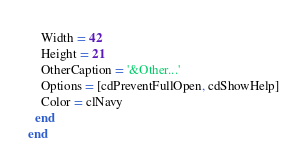Convert code to text. <code><loc_0><loc_0><loc_500><loc_500><_Pascal_>    Width = 42
    Height = 21
    OtherCaption = '&Other...'
    Options = [cdPreventFullOpen, cdShowHelp]
    Color = clNavy
  end
end
</code> 